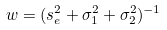<formula> <loc_0><loc_0><loc_500><loc_500>w = ( s _ { e } ^ { 2 } + \sigma _ { 1 } ^ { 2 } + \sigma _ { 2 } ^ { 2 } ) ^ { - 1 }</formula> 